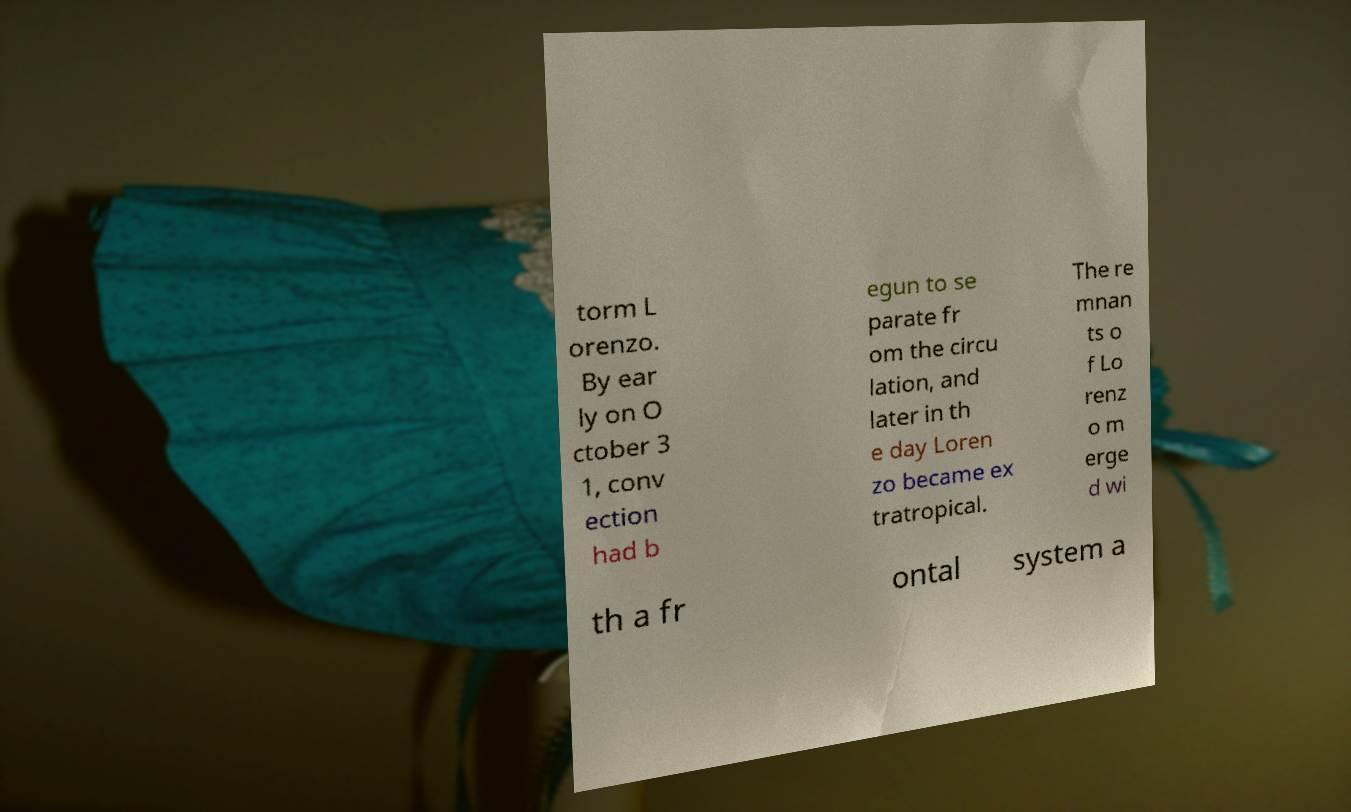Could you assist in decoding the text presented in this image and type it out clearly? torm L orenzo. By ear ly on O ctober 3 1, conv ection had b egun to se parate fr om the circu lation, and later in th e day Loren zo became ex tratropical. The re mnan ts o f Lo renz o m erge d wi th a fr ontal system a 